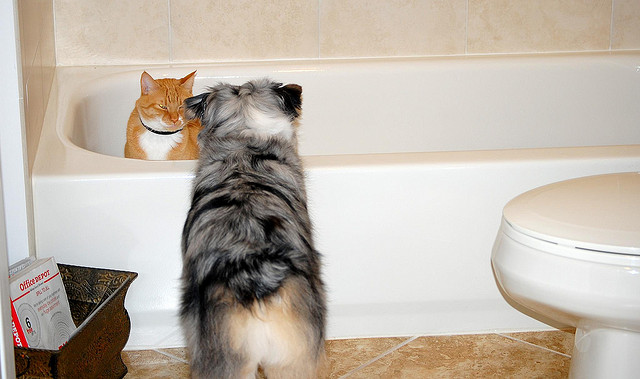Please transcribe the text in this image. 6 